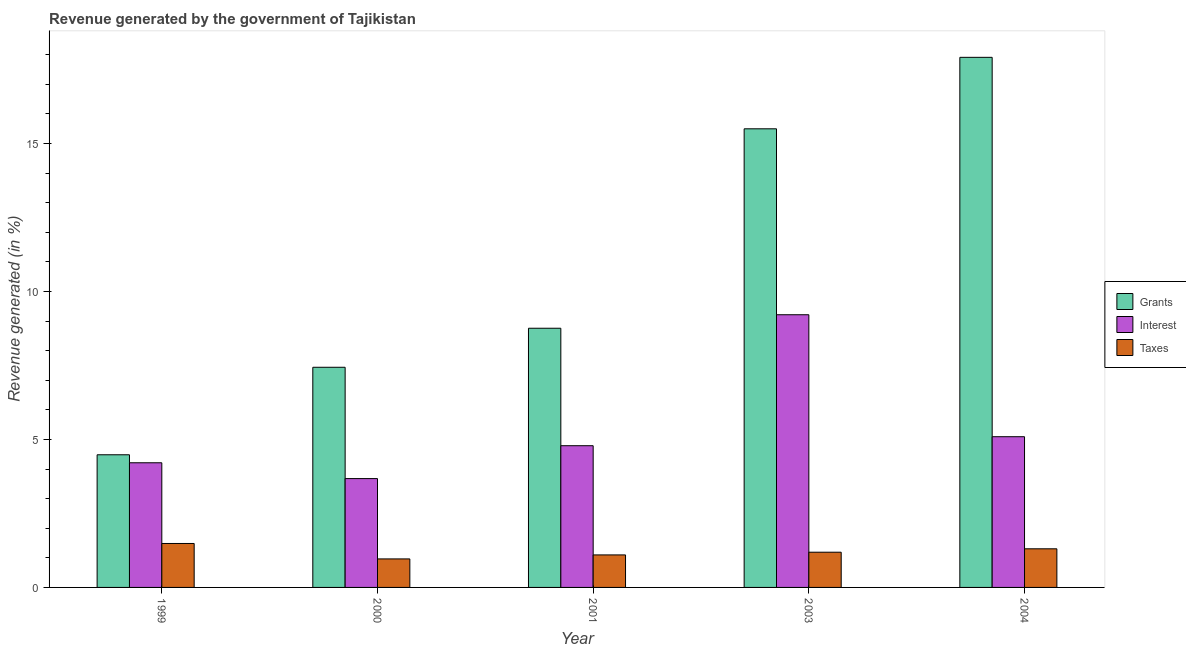How many different coloured bars are there?
Give a very brief answer. 3. How many groups of bars are there?
Offer a terse response. 5. Are the number of bars per tick equal to the number of legend labels?
Ensure brevity in your answer.  Yes. Are the number of bars on each tick of the X-axis equal?
Offer a terse response. Yes. How many bars are there on the 2nd tick from the left?
Your response must be concise. 3. What is the label of the 2nd group of bars from the left?
Keep it short and to the point. 2000. In how many cases, is the number of bars for a given year not equal to the number of legend labels?
Your answer should be compact. 0. What is the percentage of revenue generated by taxes in 2004?
Your answer should be very brief. 1.3. Across all years, what is the maximum percentage of revenue generated by grants?
Ensure brevity in your answer.  17.91. Across all years, what is the minimum percentage of revenue generated by grants?
Make the answer very short. 4.48. In which year was the percentage of revenue generated by taxes minimum?
Provide a succinct answer. 2000. What is the total percentage of revenue generated by grants in the graph?
Your response must be concise. 54.08. What is the difference between the percentage of revenue generated by taxes in 2003 and that in 2004?
Your answer should be compact. -0.12. What is the difference between the percentage of revenue generated by grants in 2000 and the percentage of revenue generated by interest in 1999?
Offer a terse response. 2.96. What is the average percentage of revenue generated by taxes per year?
Your answer should be compact. 1.21. In how many years, is the percentage of revenue generated by grants greater than 11 %?
Give a very brief answer. 2. What is the ratio of the percentage of revenue generated by interest in 2001 to that in 2003?
Your response must be concise. 0.52. Is the percentage of revenue generated by taxes in 2001 less than that in 2003?
Ensure brevity in your answer.  Yes. What is the difference between the highest and the second highest percentage of revenue generated by interest?
Your answer should be compact. 4.12. What is the difference between the highest and the lowest percentage of revenue generated by grants?
Ensure brevity in your answer.  13.43. Is the sum of the percentage of revenue generated by taxes in 2001 and 2003 greater than the maximum percentage of revenue generated by interest across all years?
Your answer should be very brief. Yes. What does the 2nd bar from the left in 1999 represents?
Provide a succinct answer. Interest. What does the 1st bar from the right in 2001 represents?
Give a very brief answer. Taxes. Is it the case that in every year, the sum of the percentage of revenue generated by grants and percentage of revenue generated by interest is greater than the percentage of revenue generated by taxes?
Offer a very short reply. Yes. Are all the bars in the graph horizontal?
Keep it short and to the point. No. How many years are there in the graph?
Offer a terse response. 5. Does the graph contain grids?
Keep it short and to the point. No. How are the legend labels stacked?
Your answer should be very brief. Vertical. What is the title of the graph?
Make the answer very short. Revenue generated by the government of Tajikistan. What is the label or title of the Y-axis?
Your response must be concise. Revenue generated (in %). What is the Revenue generated (in %) in Grants in 1999?
Your answer should be compact. 4.48. What is the Revenue generated (in %) of Interest in 1999?
Ensure brevity in your answer.  4.21. What is the Revenue generated (in %) in Taxes in 1999?
Your answer should be very brief. 1.48. What is the Revenue generated (in %) of Grants in 2000?
Ensure brevity in your answer.  7.44. What is the Revenue generated (in %) in Interest in 2000?
Offer a terse response. 3.68. What is the Revenue generated (in %) in Taxes in 2000?
Provide a short and direct response. 0.96. What is the Revenue generated (in %) of Grants in 2001?
Keep it short and to the point. 8.76. What is the Revenue generated (in %) of Interest in 2001?
Your response must be concise. 4.79. What is the Revenue generated (in %) of Taxes in 2001?
Your answer should be compact. 1.1. What is the Revenue generated (in %) in Grants in 2003?
Your response must be concise. 15.5. What is the Revenue generated (in %) of Interest in 2003?
Give a very brief answer. 9.21. What is the Revenue generated (in %) in Taxes in 2003?
Provide a short and direct response. 1.19. What is the Revenue generated (in %) of Grants in 2004?
Make the answer very short. 17.91. What is the Revenue generated (in %) of Interest in 2004?
Give a very brief answer. 5.09. What is the Revenue generated (in %) of Taxes in 2004?
Ensure brevity in your answer.  1.3. Across all years, what is the maximum Revenue generated (in %) of Grants?
Provide a succinct answer. 17.91. Across all years, what is the maximum Revenue generated (in %) of Interest?
Provide a succinct answer. 9.21. Across all years, what is the maximum Revenue generated (in %) in Taxes?
Provide a succinct answer. 1.48. Across all years, what is the minimum Revenue generated (in %) in Grants?
Your answer should be compact. 4.48. Across all years, what is the minimum Revenue generated (in %) of Interest?
Give a very brief answer. 3.68. Across all years, what is the minimum Revenue generated (in %) of Taxes?
Offer a very short reply. 0.96. What is the total Revenue generated (in %) of Grants in the graph?
Keep it short and to the point. 54.08. What is the total Revenue generated (in %) in Interest in the graph?
Offer a very short reply. 26.98. What is the total Revenue generated (in %) of Taxes in the graph?
Your answer should be compact. 6.04. What is the difference between the Revenue generated (in %) in Grants in 1999 and that in 2000?
Make the answer very short. -2.96. What is the difference between the Revenue generated (in %) in Interest in 1999 and that in 2000?
Offer a terse response. 0.53. What is the difference between the Revenue generated (in %) of Taxes in 1999 and that in 2000?
Make the answer very short. 0.52. What is the difference between the Revenue generated (in %) of Grants in 1999 and that in 2001?
Keep it short and to the point. -4.28. What is the difference between the Revenue generated (in %) of Interest in 1999 and that in 2001?
Your answer should be compact. -0.58. What is the difference between the Revenue generated (in %) of Taxes in 1999 and that in 2001?
Your answer should be very brief. 0.39. What is the difference between the Revenue generated (in %) of Grants in 1999 and that in 2003?
Make the answer very short. -11.01. What is the difference between the Revenue generated (in %) in Interest in 1999 and that in 2003?
Give a very brief answer. -5. What is the difference between the Revenue generated (in %) in Taxes in 1999 and that in 2003?
Give a very brief answer. 0.29. What is the difference between the Revenue generated (in %) of Grants in 1999 and that in 2004?
Offer a very short reply. -13.43. What is the difference between the Revenue generated (in %) of Interest in 1999 and that in 2004?
Provide a short and direct response. -0.88. What is the difference between the Revenue generated (in %) in Taxes in 1999 and that in 2004?
Offer a terse response. 0.18. What is the difference between the Revenue generated (in %) in Grants in 2000 and that in 2001?
Your response must be concise. -1.32. What is the difference between the Revenue generated (in %) of Interest in 2000 and that in 2001?
Your answer should be very brief. -1.11. What is the difference between the Revenue generated (in %) of Taxes in 2000 and that in 2001?
Your answer should be compact. -0.14. What is the difference between the Revenue generated (in %) in Grants in 2000 and that in 2003?
Offer a very short reply. -8.06. What is the difference between the Revenue generated (in %) of Interest in 2000 and that in 2003?
Your answer should be compact. -5.54. What is the difference between the Revenue generated (in %) of Taxes in 2000 and that in 2003?
Provide a short and direct response. -0.23. What is the difference between the Revenue generated (in %) in Grants in 2000 and that in 2004?
Provide a short and direct response. -10.47. What is the difference between the Revenue generated (in %) of Interest in 2000 and that in 2004?
Keep it short and to the point. -1.41. What is the difference between the Revenue generated (in %) of Taxes in 2000 and that in 2004?
Your answer should be compact. -0.34. What is the difference between the Revenue generated (in %) of Grants in 2001 and that in 2003?
Your response must be concise. -6.74. What is the difference between the Revenue generated (in %) of Interest in 2001 and that in 2003?
Offer a very short reply. -4.42. What is the difference between the Revenue generated (in %) of Taxes in 2001 and that in 2003?
Offer a very short reply. -0.09. What is the difference between the Revenue generated (in %) in Grants in 2001 and that in 2004?
Give a very brief answer. -9.15. What is the difference between the Revenue generated (in %) of Interest in 2001 and that in 2004?
Ensure brevity in your answer.  -0.3. What is the difference between the Revenue generated (in %) in Taxes in 2001 and that in 2004?
Provide a succinct answer. -0.21. What is the difference between the Revenue generated (in %) of Grants in 2003 and that in 2004?
Ensure brevity in your answer.  -2.42. What is the difference between the Revenue generated (in %) in Interest in 2003 and that in 2004?
Provide a short and direct response. 4.12. What is the difference between the Revenue generated (in %) in Taxes in 2003 and that in 2004?
Ensure brevity in your answer.  -0.12. What is the difference between the Revenue generated (in %) of Grants in 1999 and the Revenue generated (in %) of Interest in 2000?
Offer a terse response. 0.8. What is the difference between the Revenue generated (in %) of Grants in 1999 and the Revenue generated (in %) of Taxes in 2000?
Your response must be concise. 3.52. What is the difference between the Revenue generated (in %) in Interest in 1999 and the Revenue generated (in %) in Taxes in 2000?
Give a very brief answer. 3.25. What is the difference between the Revenue generated (in %) of Grants in 1999 and the Revenue generated (in %) of Interest in 2001?
Give a very brief answer. -0.31. What is the difference between the Revenue generated (in %) of Grants in 1999 and the Revenue generated (in %) of Taxes in 2001?
Your response must be concise. 3.38. What is the difference between the Revenue generated (in %) in Interest in 1999 and the Revenue generated (in %) in Taxes in 2001?
Give a very brief answer. 3.11. What is the difference between the Revenue generated (in %) in Grants in 1999 and the Revenue generated (in %) in Interest in 2003?
Keep it short and to the point. -4.73. What is the difference between the Revenue generated (in %) in Grants in 1999 and the Revenue generated (in %) in Taxes in 2003?
Provide a short and direct response. 3.29. What is the difference between the Revenue generated (in %) in Interest in 1999 and the Revenue generated (in %) in Taxes in 2003?
Provide a short and direct response. 3.02. What is the difference between the Revenue generated (in %) of Grants in 1999 and the Revenue generated (in %) of Interest in 2004?
Offer a terse response. -0.61. What is the difference between the Revenue generated (in %) of Grants in 1999 and the Revenue generated (in %) of Taxes in 2004?
Your answer should be very brief. 3.18. What is the difference between the Revenue generated (in %) in Interest in 1999 and the Revenue generated (in %) in Taxes in 2004?
Offer a terse response. 2.91. What is the difference between the Revenue generated (in %) in Grants in 2000 and the Revenue generated (in %) in Interest in 2001?
Your response must be concise. 2.65. What is the difference between the Revenue generated (in %) in Grants in 2000 and the Revenue generated (in %) in Taxes in 2001?
Your answer should be very brief. 6.34. What is the difference between the Revenue generated (in %) in Interest in 2000 and the Revenue generated (in %) in Taxes in 2001?
Keep it short and to the point. 2.58. What is the difference between the Revenue generated (in %) of Grants in 2000 and the Revenue generated (in %) of Interest in 2003?
Keep it short and to the point. -1.77. What is the difference between the Revenue generated (in %) of Grants in 2000 and the Revenue generated (in %) of Taxes in 2003?
Keep it short and to the point. 6.25. What is the difference between the Revenue generated (in %) in Interest in 2000 and the Revenue generated (in %) in Taxes in 2003?
Your answer should be very brief. 2.49. What is the difference between the Revenue generated (in %) in Grants in 2000 and the Revenue generated (in %) in Interest in 2004?
Offer a terse response. 2.35. What is the difference between the Revenue generated (in %) of Grants in 2000 and the Revenue generated (in %) of Taxes in 2004?
Your answer should be compact. 6.13. What is the difference between the Revenue generated (in %) in Interest in 2000 and the Revenue generated (in %) in Taxes in 2004?
Make the answer very short. 2.37. What is the difference between the Revenue generated (in %) of Grants in 2001 and the Revenue generated (in %) of Interest in 2003?
Give a very brief answer. -0.46. What is the difference between the Revenue generated (in %) in Grants in 2001 and the Revenue generated (in %) in Taxes in 2003?
Make the answer very short. 7.57. What is the difference between the Revenue generated (in %) of Interest in 2001 and the Revenue generated (in %) of Taxes in 2003?
Your answer should be very brief. 3.6. What is the difference between the Revenue generated (in %) of Grants in 2001 and the Revenue generated (in %) of Interest in 2004?
Provide a short and direct response. 3.66. What is the difference between the Revenue generated (in %) in Grants in 2001 and the Revenue generated (in %) in Taxes in 2004?
Your response must be concise. 7.45. What is the difference between the Revenue generated (in %) in Interest in 2001 and the Revenue generated (in %) in Taxes in 2004?
Offer a very short reply. 3.48. What is the difference between the Revenue generated (in %) in Grants in 2003 and the Revenue generated (in %) in Interest in 2004?
Provide a short and direct response. 10.4. What is the difference between the Revenue generated (in %) in Grants in 2003 and the Revenue generated (in %) in Taxes in 2004?
Provide a short and direct response. 14.19. What is the difference between the Revenue generated (in %) in Interest in 2003 and the Revenue generated (in %) in Taxes in 2004?
Your answer should be compact. 7.91. What is the average Revenue generated (in %) of Grants per year?
Your response must be concise. 10.82. What is the average Revenue generated (in %) in Interest per year?
Provide a succinct answer. 5.4. What is the average Revenue generated (in %) in Taxes per year?
Give a very brief answer. 1.21. In the year 1999, what is the difference between the Revenue generated (in %) in Grants and Revenue generated (in %) in Interest?
Your answer should be compact. 0.27. In the year 1999, what is the difference between the Revenue generated (in %) of Grants and Revenue generated (in %) of Taxes?
Provide a succinct answer. 3. In the year 1999, what is the difference between the Revenue generated (in %) of Interest and Revenue generated (in %) of Taxes?
Make the answer very short. 2.73. In the year 2000, what is the difference between the Revenue generated (in %) in Grants and Revenue generated (in %) in Interest?
Offer a very short reply. 3.76. In the year 2000, what is the difference between the Revenue generated (in %) of Grants and Revenue generated (in %) of Taxes?
Your answer should be compact. 6.48. In the year 2000, what is the difference between the Revenue generated (in %) of Interest and Revenue generated (in %) of Taxes?
Offer a terse response. 2.71. In the year 2001, what is the difference between the Revenue generated (in %) in Grants and Revenue generated (in %) in Interest?
Make the answer very short. 3.97. In the year 2001, what is the difference between the Revenue generated (in %) of Grants and Revenue generated (in %) of Taxes?
Offer a very short reply. 7.66. In the year 2001, what is the difference between the Revenue generated (in %) in Interest and Revenue generated (in %) in Taxes?
Keep it short and to the point. 3.69. In the year 2003, what is the difference between the Revenue generated (in %) of Grants and Revenue generated (in %) of Interest?
Ensure brevity in your answer.  6.28. In the year 2003, what is the difference between the Revenue generated (in %) of Grants and Revenue generated (in %) of Taxes?
Make the answer very short. 14.31. In the year 2003, what is the difference between the Revenue generated (in %) of Interest and Revenue generated (in %) of Taxes?
Your response must be concise. 8.02. In the year 2004, what is the difference between the Revenue generated (in %) in Grants and Revenue generated (in %) in Interest?
Ensure brevity in your answer.  12.82. In the year 2004, what is the difference between the Revenue generated (in %) in Grants and Revenue generated (in %) in Taxes?
Provide a short and direct response. 16.61. In the year 2004, what is the difference between the Revenue generated (in %) in Interest and Revenue generated (in %) in Taxes?
Offer a terse response. 3.79. What is the ratio of the Revenue generated (in %) of Grants in 1999 to that in 2000?
Offer a terse response. 0.6. What is the ratio of the Revenue generated (in %) of Interest in 1999 to that in 2000?
Provide a short and direct response. 1.15. What is the ratio of the Revenue generated (in %) in Taxes in 1999 to that in 2000?
Your answer should be very brief. 1.54. What is the ratio of the Revenue generated (in %) of Grants in 1999 to that in 2001?
Your answer should be very brief. 0.51. What is the ratio of the Revenue generated (in %) of Interest in 1999 to that in 2001?
Your answer should be very brief. 0.88. What is the ratio of the Revenue generated (in %) of Taxes in 1999 to that in 2001?
Make the answer very short. 1.35. What is the ratio of the Revenue generated (in %) in Grants in 1999 to that in 2003?
Provide a short and direct response. 0.29. What is the ratio of the Revenue generated (in %) in Interest in 1999 to that in 2003?
Your answer should be very brief. 0.46. What is the ratio of the Revenue generated (in %) of Taxes in 1999 to that in 2003?
Give a very brief answer. 1.25. What is the ratio of the Revenue generated (in %) in Grants in 1999 to that in 2004?
Your answer should be very brief. 0.25. What is the ratio of the Revenue generated (in %) of Interest in 1999 to that in 2004?
Your answer should be compact. 0.83. What is the ratio of the Revenue generated (in %) of Taxes in 1999 to that in 2004?
Ensure brevity in your answer.  1.14. What is the ratio of the Revenue generated (in %) in Grants in 2000 to that in 2001?
Give a very brief answer. 0.85. What is the ratio of the Revenue generated (in %) in Interest in 2000 to that in 2001?
Your response must be concise. 0.77. What is the ratio of the Revenue generated (in %) in Taxes in 2000 to that in 2001?
Provide a short and direct response. 0.88. What is the ratio of the Revenue generated (in %) in Grants in 2000 to that in 2003?
Your answer should be very brief. 0.48. What is the ratio of the Revenue generated (in %) of Interest in 2000 to that in 2003?
Your response must be concise. 0.4. What is the ratio of the Revenue generated (in %) of Taxes in 2000 to that in 2003?
Offer a very short reply. 0.81. What is the ratio of the Revenue generated (in %) of Grants in 2000 to that in 2004?
Give a very brief answer. 0.42. What is the ratio of the Revenue generated (in %) in Interest in 2000 to that in 2004?
Your response must be concise. 0.72. What is the ratio of the Revenue generated (in %) of Taxes in 2000 to that in 2004?
Your answer should be compact. 0.74. What is the ratio of the Revenue generated (in %) in Grants in 2001 to that in 2003?
Offer a very short reply. 0.57. What is the ratio of the Revenue generated (in %) of Interest in 2001 to that in 2003?
Keep it short and to the point. 0.52. What is the ratio of the Revenue generated (in %) of Taxes in 2001 to that in 2003?
Your answer should be compact. 0.92. What is the ratio of the Revenue generated (in %) in Grants in 2001 to that in 2004?
Provide a succinct answer. 0.49. What is the ratio of the Revenue generated (in %) of Interest in 2001 to that in 2004?
Offer a terse response. 0.94. What is the ratio of the Revenue generated (in %) in Taxes in 2001 to that in 2004?
Offer a terse response. 0.84. What is the ratio of the Revenue generated (in %) of Grants in 2003 to that in 2004?
Provide a short and direct response. 0.87. What is the ratio of the Revenue generated (in %) of Interest in 2003 to that in 2004?
Provide a succinct answer. 1.81. What is the ratio of the Revenue generated (in %) of Taxes in 2003 to that in 2004?
Provide a succinct answer. 0.91. What is the difference between the highest and the second highest Revenue generated (in %) of Grants?
Provide a short and direct response. 2.42. What is the difference between the highest and the second highest Revenue generated (in %) in Interest?
Your response must be concise. 4.12. What is the difference between the highest and the second highest Revenue generated (in %) in Taxes?
Your response must be concise. 0.18. What is the difference between the highest and the lowest Revenue generated (in %) of Grants?
Your answer should be compact. 13.43. What is the difference between the highest and the lowest Revenue generated (in %) of Interest?
Your answer should be compact. 5.54. What is the difference between the highest and the lowest Revenue generated (in %) in Taxes?
Your response must be concise. 0.52. 